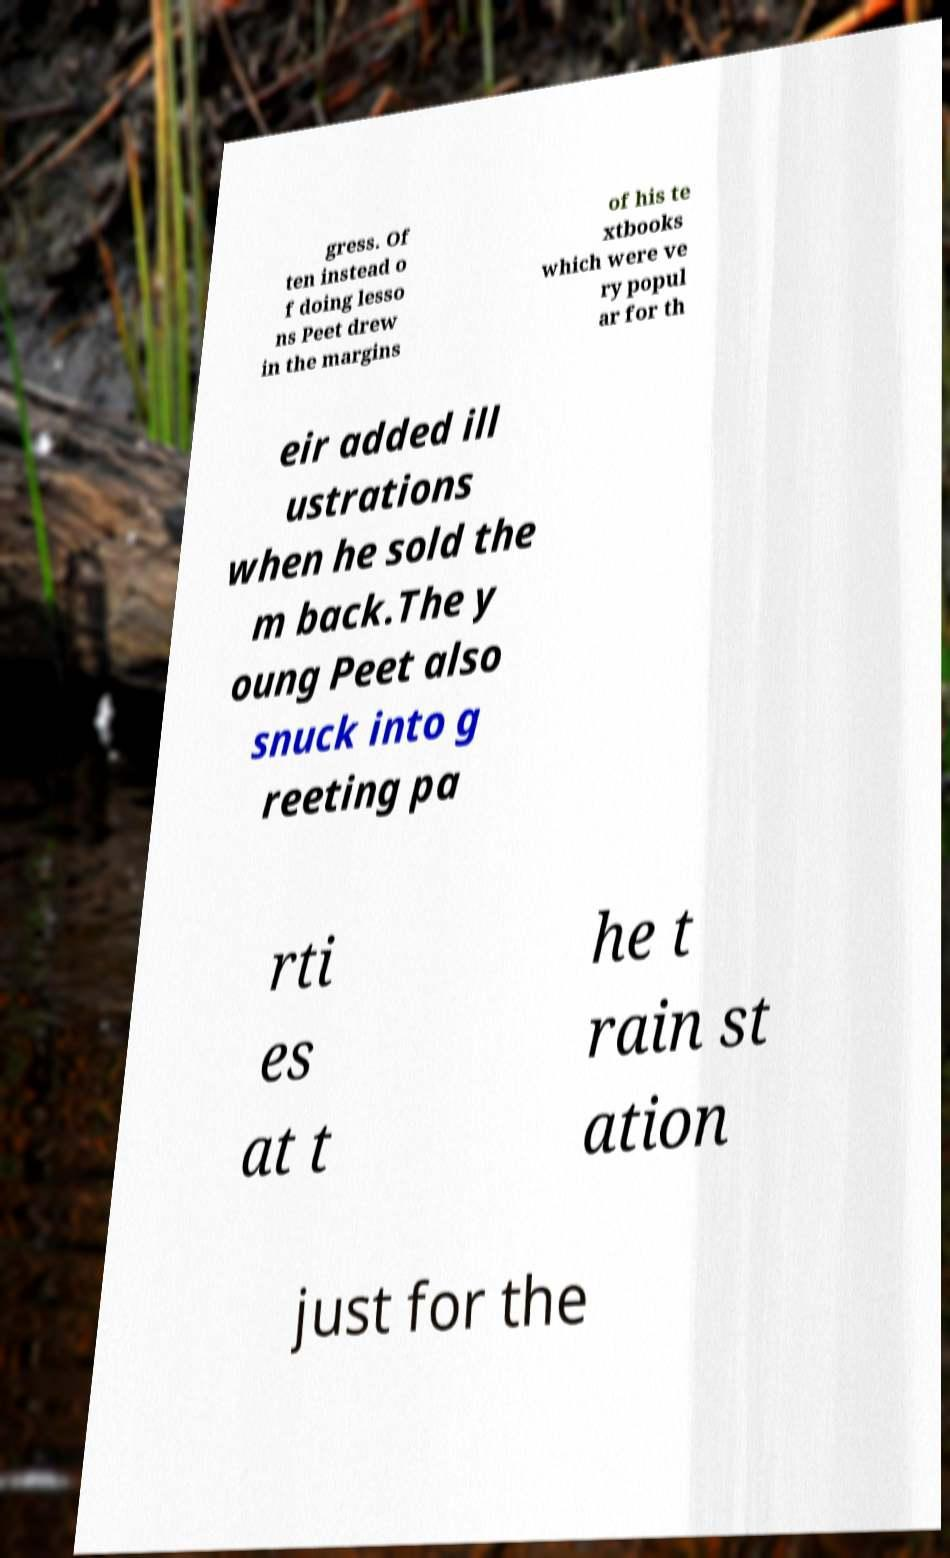There's text embedded in this image that I need extracted. Can you transcribe it verbatim? gress. Of ten instead o f doing lesso ns Peet drew in the margins of his te xtbooks which were ve ry popul ar for th eir added ill ustrations when he sold the m back.The y oung Peet also snuck into g reeting pa rti es at t he t rain st ation just for the 